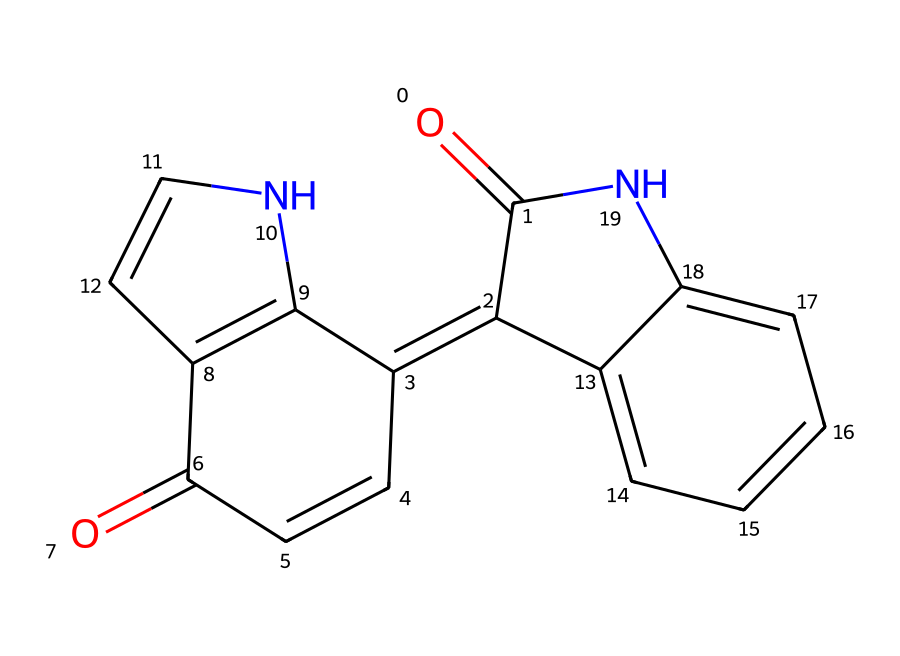What is the primary functional group present in this compound? The structure contains a carbonyl group (C=O) which is characteristic of imides; it can be identified in the structure where the C=O is bonded to a nitrogen atom.
Answer: carbonyl How many nitrogen atoms are present in the chemical structure? By examining the SMILES representation, I can identify two nitrogen atoms in the structure, each bonded to a carbon.
Answer: two What is the total number of rings present in the chemical structure? The chemical structure has four fused rings, which can be counted by analyzing the interconnected cyclic structures within the representation.
Answer: four How many total carbons are present in this compound? Counting the carbon atoms in the SMILES representation reveals that there are 14 carbon atoms in total, as deduced by identifying each carbon explicitly mentioned.
Answer: fourteen What type of dye is indicated by this chemical structure? The structure corresponds to indigo dye, which is a well-known natural dye used historically, especially in ancient textiles. The presence of the imide functional groups identifies it as such.
Answer: indigo 